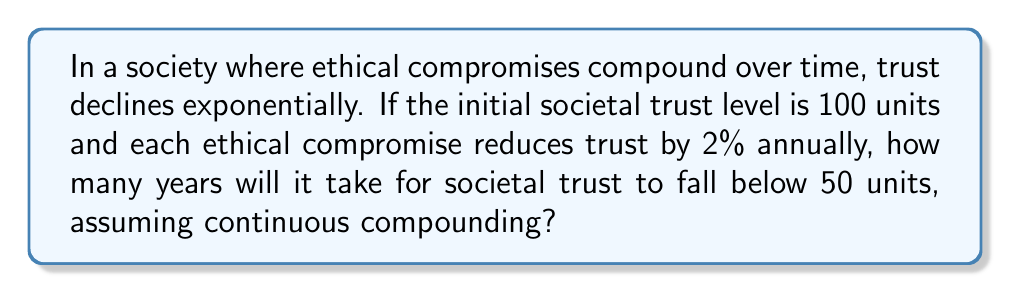Can you answer this question? To solve this problem, we'll use the continuous compound interest formula and solve for time:

1. The continuous compound interest formula is:
   $$ A = P \cdot e^{rt} $$
   Where:
   $A$ is the final amount
   $P$ is the initial amount
   $r$ is the rate (as a decimal)
   $t$ is time in years
   $e$ is Euler's number

2. In this case:
   $A = 50$ (the target trust level)
   $P = 100$ (initial trust level)
   $r = -0.02$ (negative because trust is decreasing)
   We need to solve for $t$

3. Plugging in the values:
   $$ 50 = 100 \cdot e^{-0.02t} $$

4. Divide both sides by 100:
   $$ 0.5 = e^{-0.02t} $$

5. Take the natural log of both sides:
   $$ \ln(0.5) = -0.02t $$

6. Solve for $t$:
   $$ t = \frac{\ln(0.5)}{-0.02} $$

7. Calculate the result:
   $$ t = \frac{-0.693147...}{-0.02} \approx 34.66 $$

Therefore, it will take approximately 34.66 years for societal trust to fall below 50 units.
Answer: 34.66 years 